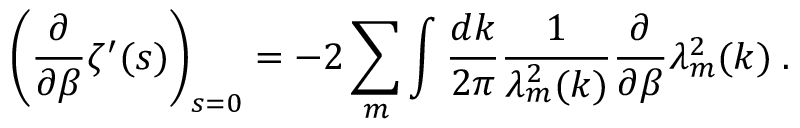Convert formula to latex. <formula><loc_0><loc_0><loc_500><loc_500>\left ( \frac { \partial } { \partial \beta } \zeta ^ { \prime } ( s ) \right ) _ { s = 0 } = - 2 \sum _ { m } \int \frac { d k } { 2 \pi } \frac { 1 } { \lambda _ { m } ^ { 2 } ( k ) } \frac { \partial } { \partial \beta } \lambda _ { m } ^ { 2 } ( k ) \, .</formula> 